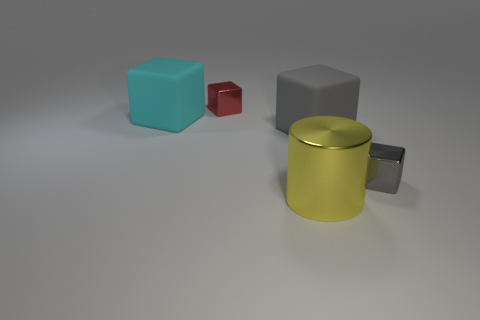Are there any other things that have the same shape as the large yellow metallic object?
Your response must be concise. No. There is a yellow cylinder; is it the same size as the rubber cube left of the large yellow metallic thing?
Offer a terse response. Yes. Is there a big brown object that has the same material as the big cylinder?
Keep it short and to the point. No. How many cylinders are big cyan objects or tiny gray things?
Offer a very short reply. 0. There is a small red cube behind the gray metal cube; is there a large cyan matte cube that is in front of it?
Give a very brief answer. Yes. Are there fewer small red shiny things than tiny shiny cylinders?
Your response must be concise. No. What number of cyan objects are the same shape as the yellow thing?
Your answer should be compact. 0. How many yellow objects are large shiny cylinders or big balls?
Offer a terse response. 1. What is the size of the gray cube that is left of the metallic thing that is on the right side of the big metallic object?
Provide a short and direct response. Large. There is another small object that is the same shape as the tiny gray metal object; what is it made of?
Offer a very short reply. Metal. 